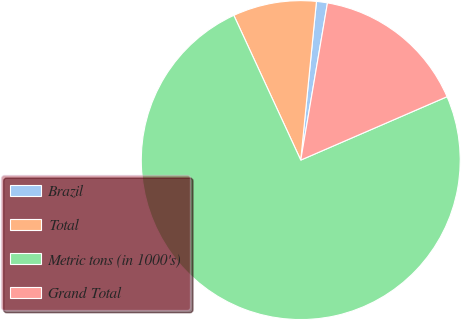Convert chart. <chart><loc_0><loc_0><loc_500><loc_500><pie_chart><fcel>Brazil<fcel>Total<fcel>Metric tons (in 1000's)<fcel>Grand Total<nl><fcel>1.11%<fcel>8.46%<fcel>74.61%<fcel>15.81%<nl></chart> 